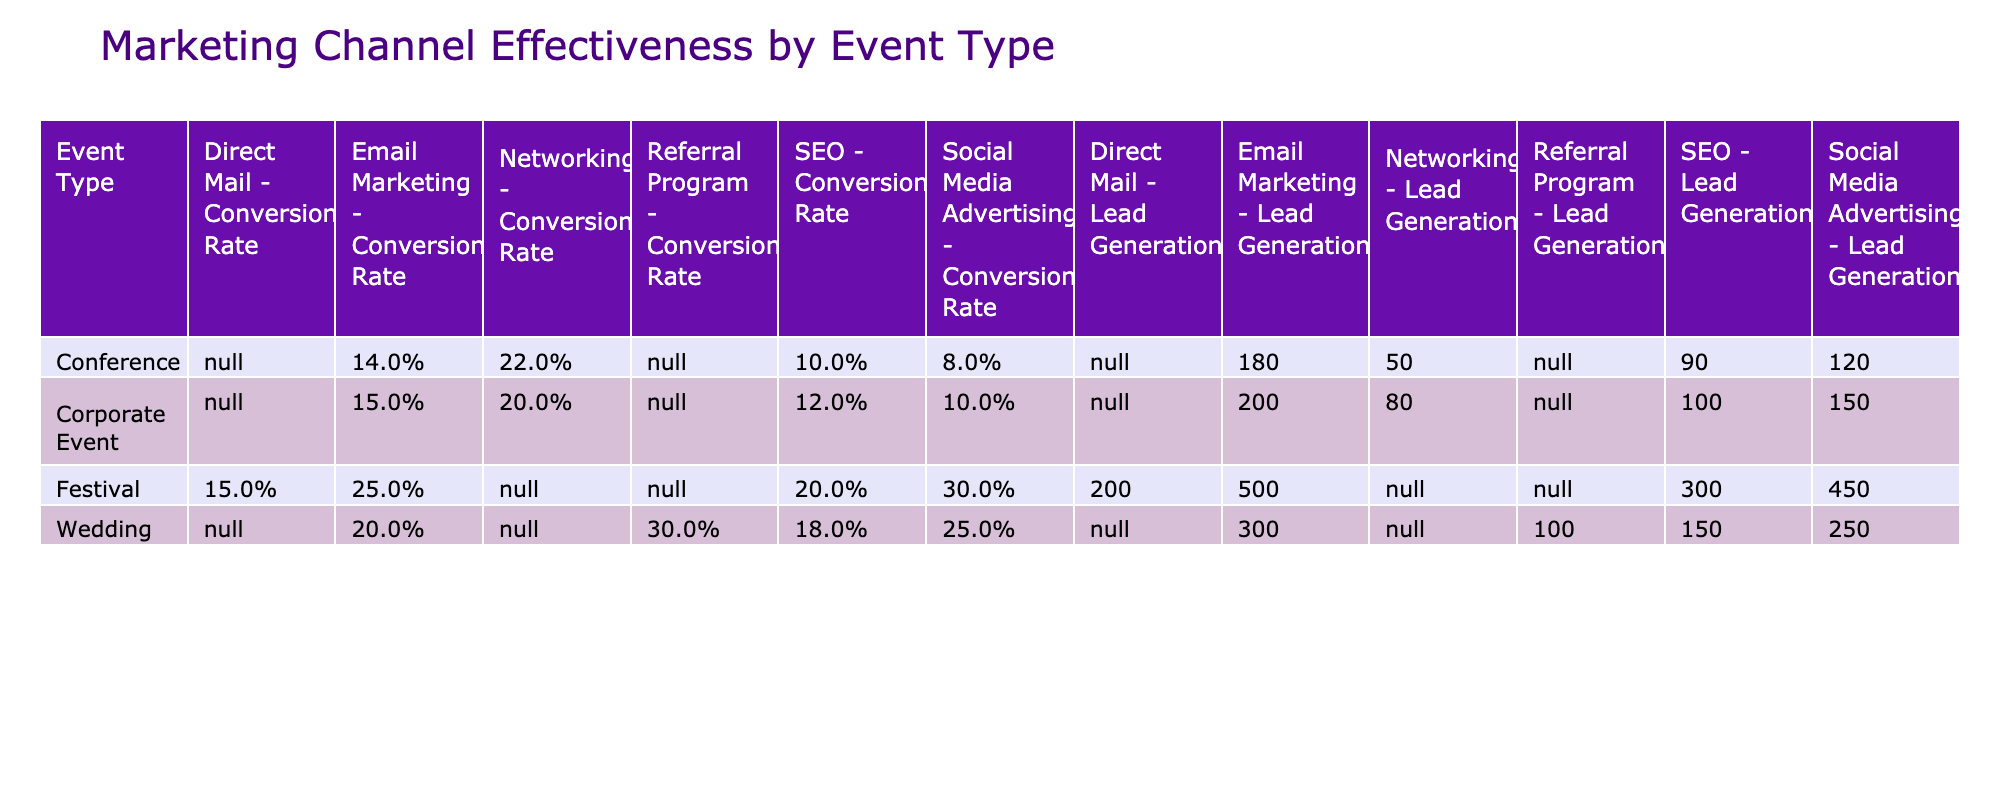What is the lead generation for Weddings using Social Media Advertising? The table shows that for Weddings, the Lead Generation from Social Media Advertising is listed as 250.
Answer: 250 Which marketing channel has the highest conversion rate for Corporate Events? In the table, Networking is noted as having a conversion rate of 20%, which is the highest among Corporate Event marketing channels, while others show lower rates of 15%, 10%, and 12%.
Answer: Networking What is the total lead generation for all Festivals? Summing the lead generation for all Festival marketing channels: Email Marketing (500) + Social Media Advertising (450) + SEO (300) + Direct Mail (200) = 1450.
Answer: 1450 Is it true that Email Marketing has a higher average conversion rate than Social Media Advertising across all events? Looking at the conversion rates: Email Marketing averages (15% + 20% + 14% + 25%) = 18.5% and Social Media Advertising averages (10% + 25% + 8% + 30%) = 18.25%. Email Marketing's average (18.5%) is indeed higher than that of Social Media Advertising (18.25%).
Answer: Yes What is the difference in lead generation between Weddings and Conferences using SEO? For Weddings, the lead generation from SEO is 150, while for Conferences it is 90. The difference is 150 - 90 = 60.
Answer: 60 Which marketing channel for Festival events has the lowest lead generation? In the Festival row, Direct Mail has the lowest lead generation, which is stated as 200, compared to higher figures from other channels (500, 450, and 300).
Answer: Direct Mail What is the average conversion rate for all marketing channels in Corporate Events? The conversion rates for Corporate Events are 15%, 10%, 12%, and 20%. The average is calculated as (15 + 10 + 12 + 20) / 4 = 14.25%.
Answer: 14.25% Is the total lead generation for Weddings higher than for Conferences? For Weddings, the total lead generation is 300 + 250 + 150 + 100 = 800. For Conferences, it is 180 + 120 + 90 + 50 = 440. Since 800 > 440, it is indeed true.
Answer: Yes Which marketing channel yields the highest lead generation in Festivals? Reviewing the Festival data, Email Marketing shows the highest lead generation at 500, more than Social Media Advertising, SEO, and Direct Mail.
Answer: Email Marketing 